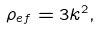<formula> <loc_0><loc_0><loc_500><loc_500>\rho _ { e f } = 3 k ^ { 2 } ,</formula> 